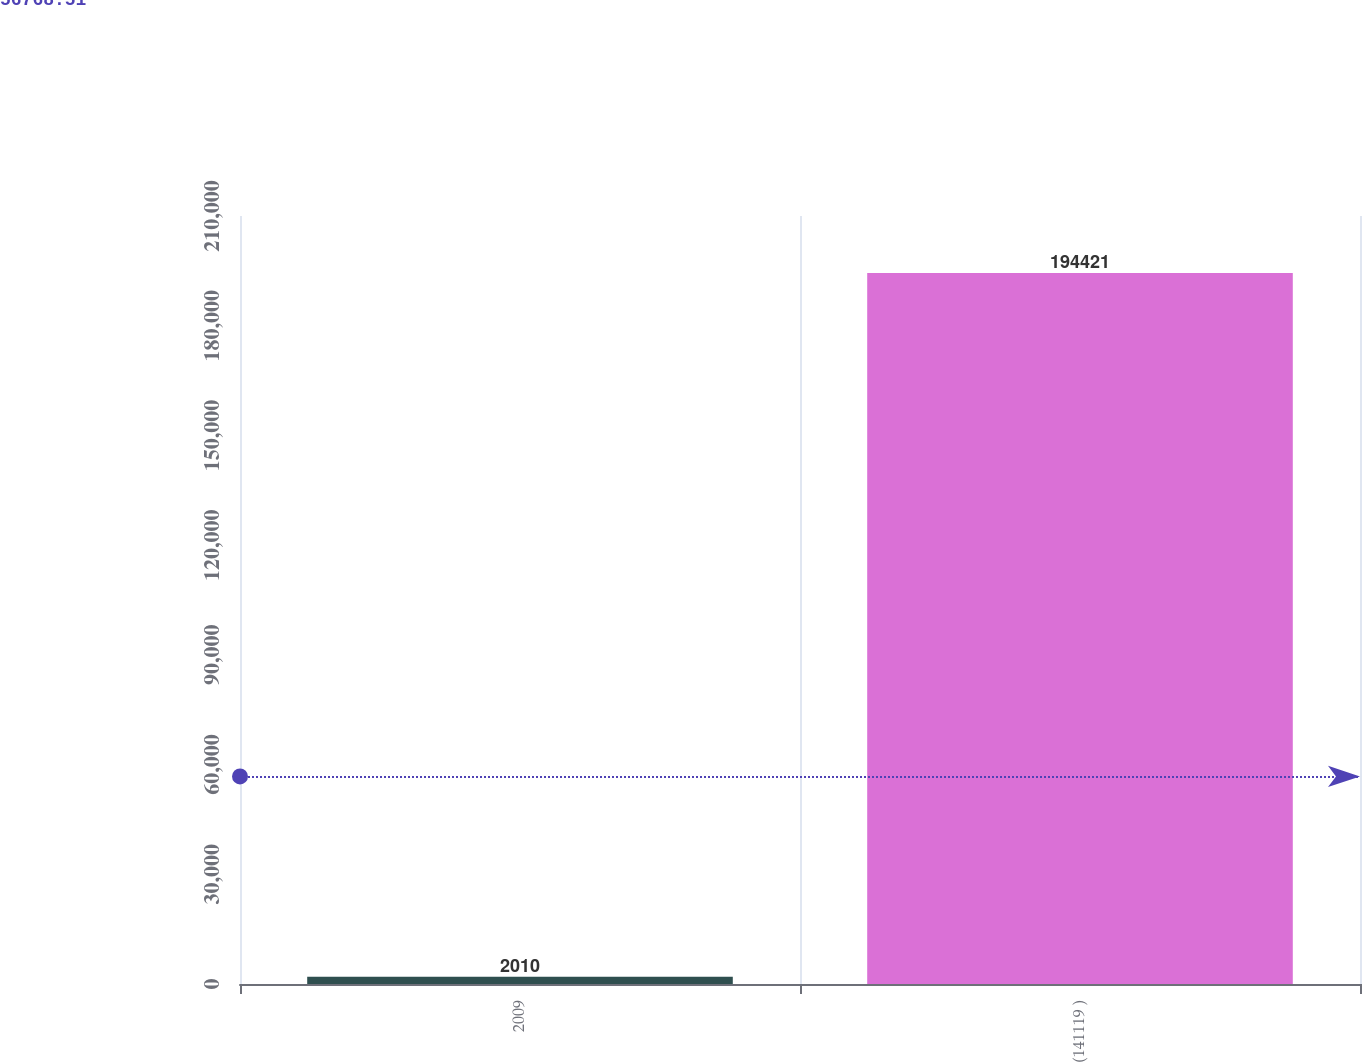<chart> <loc_0><loc_0><loc_500><loc_500><bar_chart><fcel>2009<fcel>(141119 )<nl><fcel>2010<fcel>194421<nl></chart> 